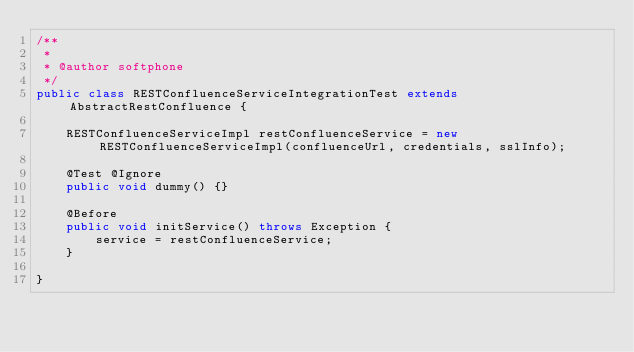<code> <loc_0><loc_0><loc_500><loc_500><_Java_>/**
 *
 * @author softphone
 */
public class RESTConfluenceServiceIntegrationTest extends AbstractRestConfluence {

    RESTConfluenceServiceImpl restConfluenceService = new RESTConfluenceServiceImpl(confluenceUrl, credentials, sslInfo);

    @Test @Ignore
    public void dummy() {}

    @Before
    public void initService() throws Exception {
        service = restConfluenceService;
    }

}
</code> 